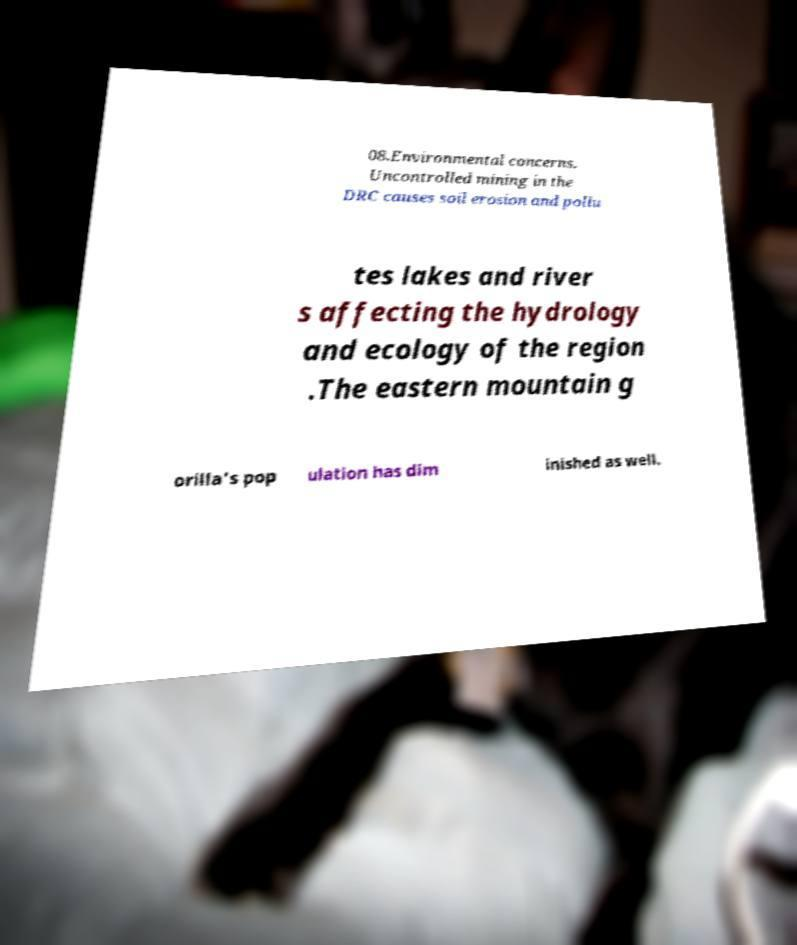Can you accurately transcribe the text from the provided image for me? 08.Environmental concerns. Uncontrolled mining in the DRC causes soil erosion and pollu tes lakes and river s affecting the hydrology and ecology of the region .The eastern mountain g orilla's pop ulation has dim inished as well. 